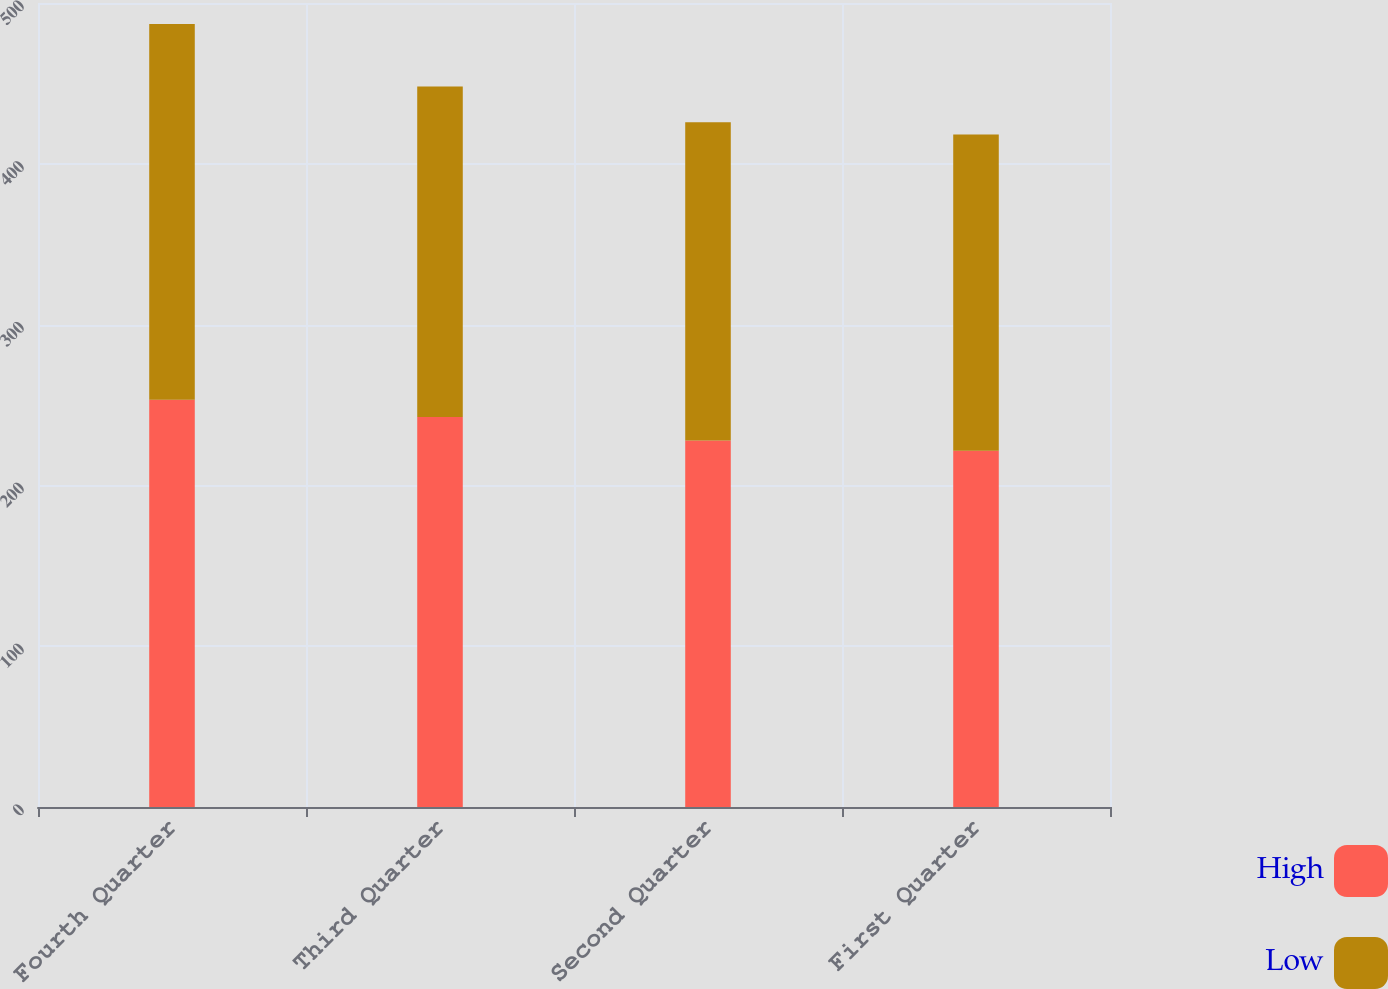Convert chart. <chart><loc_0><loc_0><loc_500><loc_500><stacked_bar_chart><ecel><fcel>Fourth Quarter<fcel>Third Quarter<fcel>Second Quarter<fcel>First Quarter<nl><fcel>High<fcel>253.27<fcel>242.56<fcel>228<fcel>221.56<nl><fcel>Low<fcel>233.71<fcel>205.55<fcel>197.91<fcel>196.72<nl></chart> 